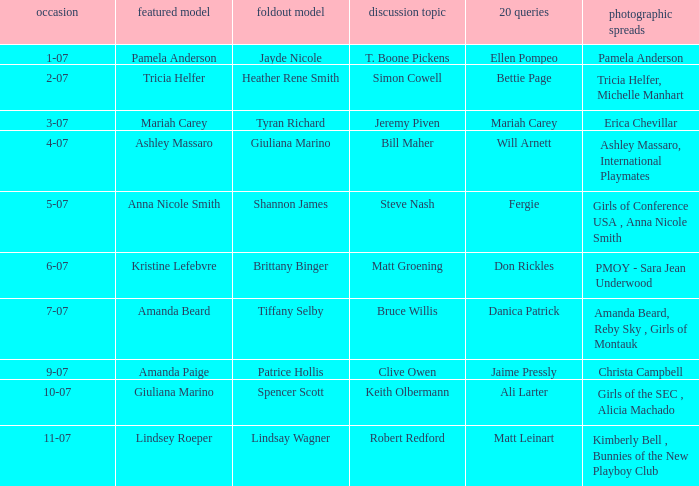Who was the featured model on the cover when the issue had sara jean underwood as the playmate of the year (pmoy)? Kristine Lefebvre. 